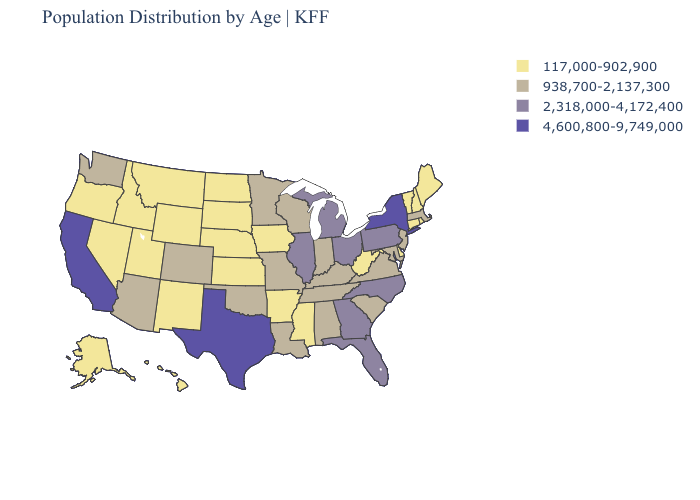Name the states that have a value in the range 2,318,000-4,172,400?
Concise answer only. Florida, Georgia, Illinois, Michigan, North Carolina, Ohio, Pennsylvania. What is the value of Illinois?
Be succinct. 2,318,000-4,172,400. Among the states that border Idaho , which have the highest value?
Short answer required. Washington. Does the map have missing data?
Short answer required. No. Among the states that border Kansas , which have the highest value?
Quick response, please. Colorado, Missouri, Oklahoma. Which states have the lowest value in the USA?
Keep it brief. Alaska, Arkansas, Connecticut, Delaware, Hawaii, Idaho, Iowa, Kansas, Maine, Mississippi, Montana, Nebraska, Nevada, New Hampshire, New Mexico, North Dakota, Oregon, Rhode Island, South Dakota, Utah, Vermont, West Virginia, Wyoming. Name the states that have a value in the range 2,318,000-4,172,400?
Keep it brief. Florida, Georgia, Illinois, Michigan, North Carolina, Ohio, Pennsylvania. What is the highest value in the USA?
Concise answer only. 4,600,800-9,749,000. Name the states that have a value in the range 938,700-2,137,300?
Be succinct. Alabama, Arizona, Colorado, Indiana, Kentucky, Louisiana, Maryland, Massachusetts, Minnesota, Missouri, New Jersey, Oklahoma, South Carolina, Tennessee, Virginia, Washington, Wisconsin. What is the lowest value in the USA?
Keep it brief. 117,000-902,900. Does the first symbol in the legend represent the smallest category?
Keep it brief. Yes. What is the lowest value in the USA?
Short answer required. 117,000-902,900. Does Idaho have the highest value in the USA?
Concise answer only. No. What is the value of Arkansas?
Keep it brief. 117,000-902,900. 